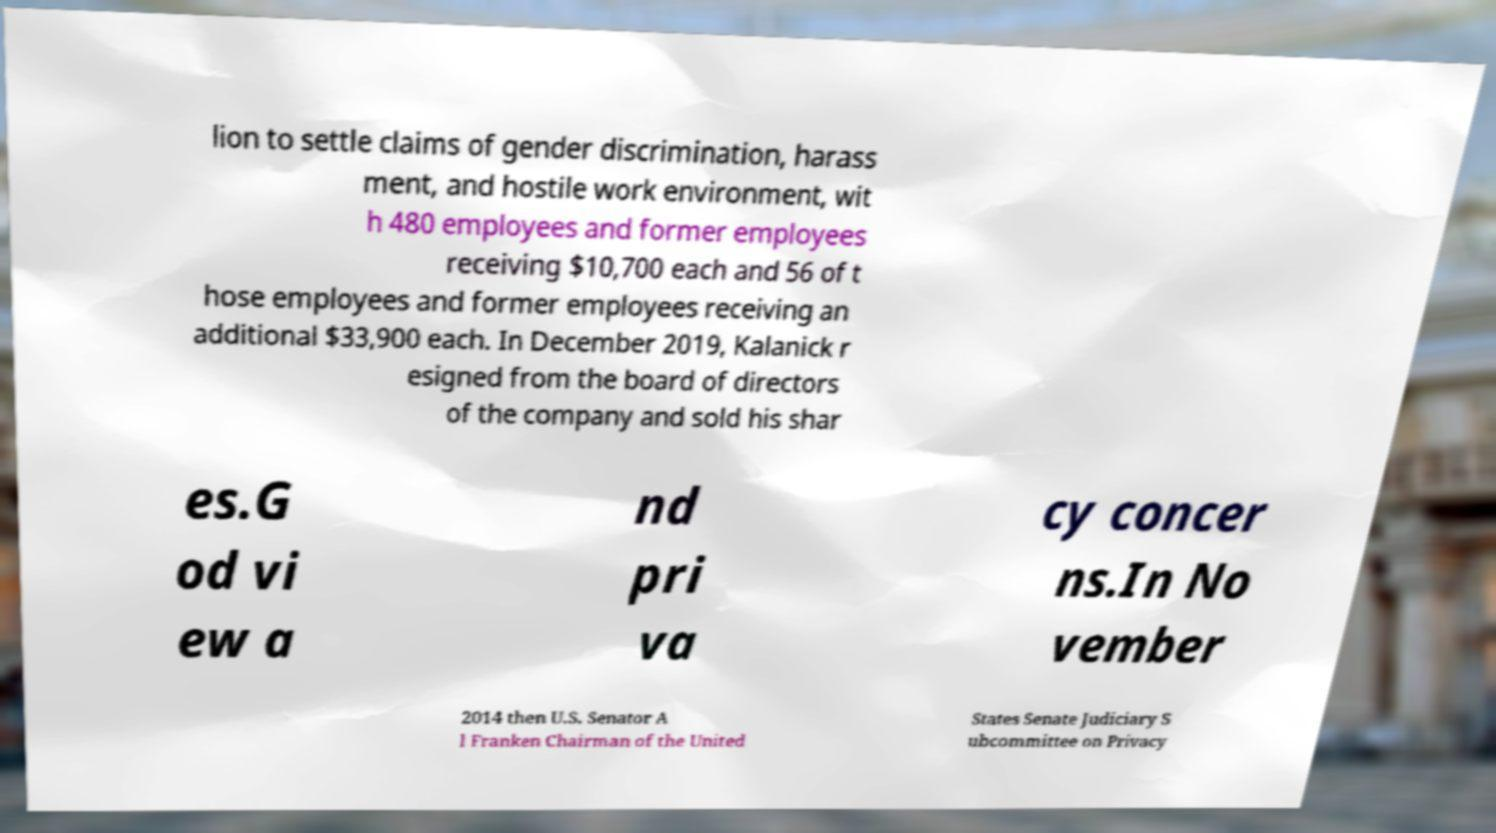I need the written content from this picture converted into text. Can you do that? lion to settle claims of gender discrimination, harass ment, and hostile work environment, wit h 480 employees and former employees receiving $10,700 each and 56 of t hose employees and former employees receiving an additional $33,900 each. In December 2019, Kalanick r esigned from the board of directors of the company and sold his shar es.G od vi ew a nd pri va cy concer ns.In No vember 2014 then U.S. Senator A l Franken Chairman of the United States Senate Judiciary S ubcommittee on Privacy 